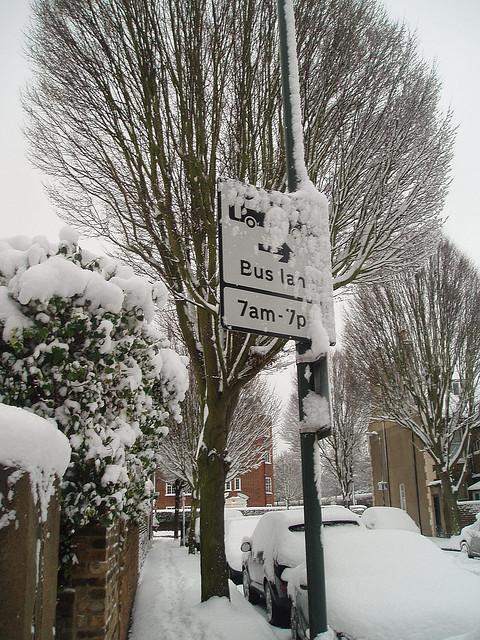What does the sign read?
Keep it brief. Bus lane. How long must you wait for a bus if you arrive at 6AM?
Give a very brief answer. 1 hour. What is the weather like?
Keep it brief. Snowy. 